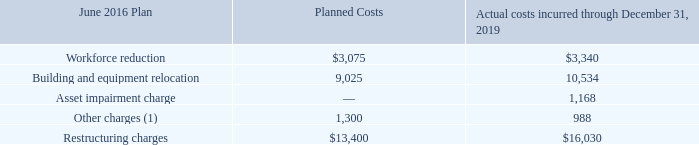NOTES TO CONSOLIDATED FINANCIAL STATEMENTS (in thousands, except for share and per share data)
NOTE 8 — Costs Associated with Exit and Restructuring Activities
2016 Plan
In June 2016, we announced plans to restructure operations by phasing out production at our Elkhart, IN facility and transitioning it into a research and development center supporting our global operations ("June 2016 Plan"). Additional organizational changes were also implemented in various other locations. In 2017, we revised this plan to include an additional $1,100 in planned costs related to the relocation of our corporate headquarters in Lisle, IL and our plant in Bolingbrook, IL, both of which have now been consolidated into a single facility. Restructuring charges under this plan, which is substantially complete, were $4,284, $4,559, and $4,139 during the years ended December 31, 2019, 2018, and 2017, respectively. The total restructuring liability related to the June 2016 Plan was $233 and $668 at December 31, 2019 and 2018, respectively. Any additional costs related to line movements, equipment charges, and other costs will be expensed as incurred.
The following table displays the restructuring charges associated with the June 2016 Plan as well as a summary of the actual costs incurred through December 31, 2019:
(1) Other charges include the effects of currency translation, travel, legal and other charges.
What were the planned costs for Other Charges?
Answer scale should be: thousand. 1,300. What were the actual restructuring costs?
Answer scale should be: thousand. 16,030. What was the actual amount of Building and Equipment Relocation costs?
Answer scale should be: thousand. 10,534. What was the difference between the planned costs and actual costs incurred for Building and Equipment Relocation?
Answer scale should be: thousand. 10,534-9,025
Answer: 1509. What was the difference between the planned costs and actual costs incurred for Workforce Reduction?
Answer scale should be: thousand. 3,340-3,075
Answer: 265. What was the difference between the planned costs and actual costs incurred for total Restructuring Charges?
Answer scale should be: thousand. 16,030-13,400
Answer: 2630. 